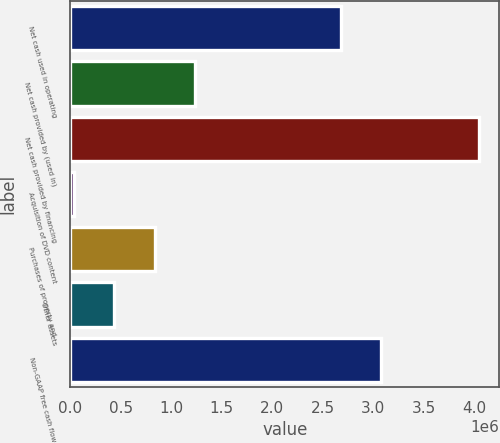<chart> <loc_0><loc_0><loc_500><loc_500><bar_chart><fcel>Net cash used in operating<fcel>Net cash provided by (used in)<fcel>Net cash provided by financing<fcel>Acquisition of DVD content<fcel>Purchases of property and<fcel>Other assets<fcel>Non-GAAP free cash flow<nl><fcel>2.68048e+06<fcel>1.24157e+06<fcel>4.04853e+06<fcel>38586<fcel>840574<fcel>439580<fcel>3.08147e+06<nl></chart> 